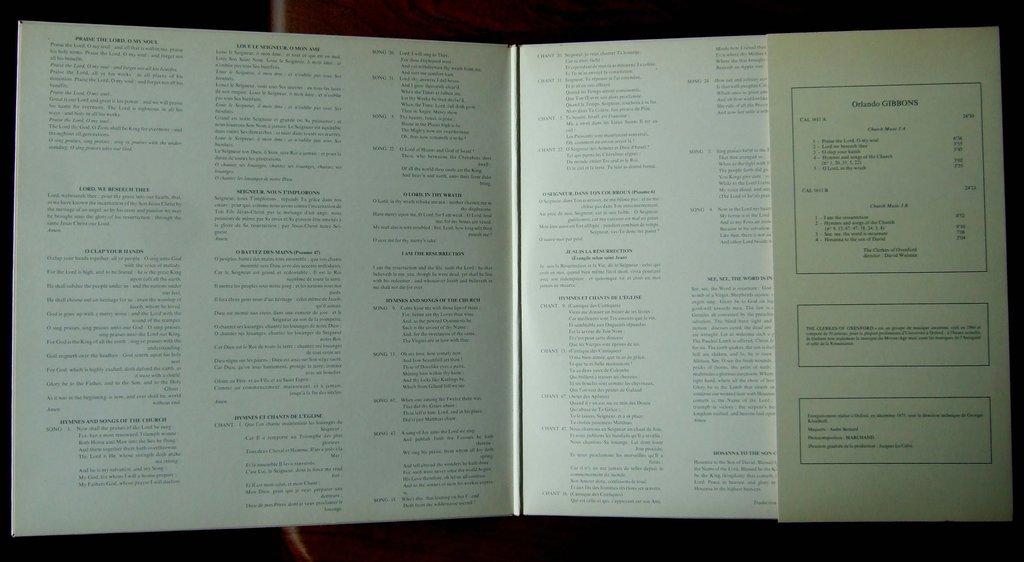What is the word following orlando?
Keep it short and to the point. Gibbons. 